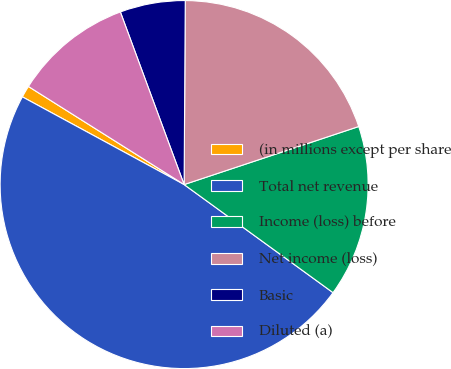<chart> <loc_0><loc_0><loc_500><loc_500><pie_chart><fcel>(in millions except per share<fcel>Total net revenue<fcel>Income (loss) before<fcel>Net income (loss)<fcel>Basic<fcel>Diluted (a)<nl><fcel>1.04%<fcel>47.91%<fcel>15.1%<fcel>19.79%<fcel>5.73%<fcel>10.42%<nl></chart> 